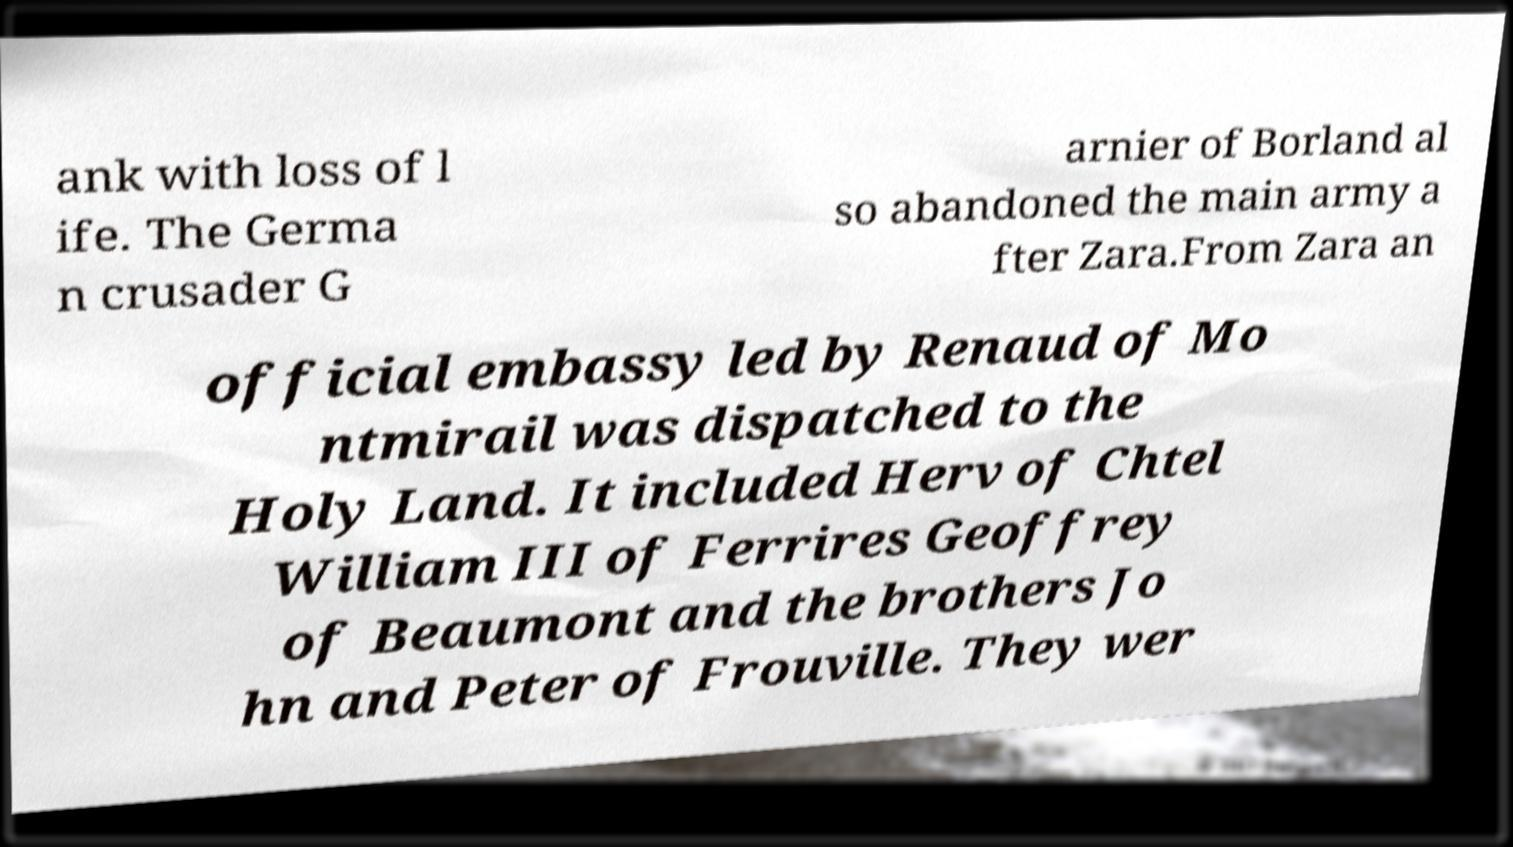Can you accurately transcribe the text from the provided image for me? ank with loss of l ife. The Germa n crusader G arnier of Borland al so abandoned the main army a fter Zara.From Zara an official embassy led by Renaud of Mo ntmirail was dispatched to the Holy Land. It included Herv of Chtel William III of Ferrires Geoffrey of Beaumont and the brothers Jo hn and Peter of Frouville. They wer 